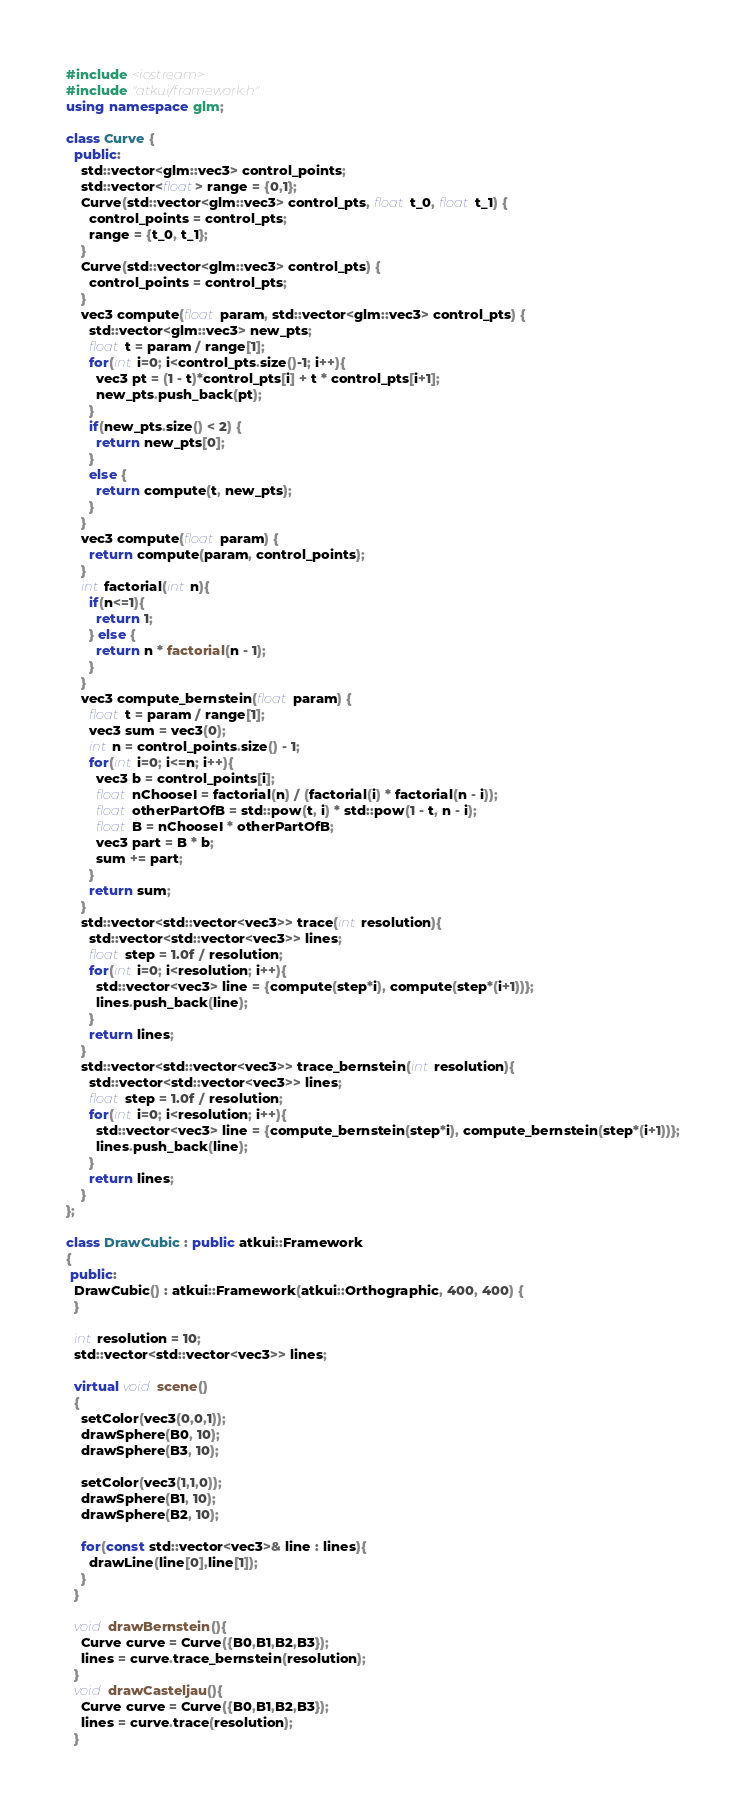Convert code to text. <code><loc_0><loc_0><loc_500><loc_500><_C++_>#include <iostream>
#include "atkui/framework.h"
using namespace glm;

class Curve {
  public:
    std::vector<glm::vec3> control_points;
    std::vector<float> range = {0,1};
    Curve(std::vector<glm::vec3> control_pts, float t_0, float t_1) {
      control_points = control_pts;
      range = {t_0, t_1};
    }
    Curve(std::vector<glm::vec3> control_pts) {
      control_points = control_pts;
    }
    vec3 compute(float param, std::vector<glm::vec3> control_pts) {
      std::vector<glm::vec3> new_pts;
      float t = param / range[1];
      for(int i=0; i<control_pts.size()-1; i++){
        vec3 pt = (1 - t)*control_pts[i] + t * control_pts[i+1];
        new_pts.push_back(pt);
      }
      if(new_pts.size() < 2) {
        return new_pts[0];
      }
      else {
        return compute(t, new_pts);
      }
    }
    vec3 compute(float param) {
      return compute(param, control_points);
    }
    int factorial(int n){
      if(n<=1){
        return 1;
      } else {
        return n * factorial(n - 1);
      }
    }
    vec3 compute_bernstein(float param) {
      float t = param / range[1];
      vec3 sum = vec3(0);
      int n = control_points.size() - 1;
      for(int i=0; i<=n; i++){
        vec3 b = control_points[i];
        float nChooseI = factorial(n) / (factorial(i) * factorial(n - i));
        float otherPartOfB = std::pow(t, i) * std::pow(1 - t, n - i);
        float B = nChooseI * otherPartOfB;
        vec3 part = B * b;
        sum += part;
      }
      return sum;
    }
    std::vector<std::vector<vec3>> trace(int resolution){
      std::vector<std::vector<vec3>> lines;
      float step = 1.0f / resolution;
      for(int i=0; i<resolution; i++){
        std::vector<vec3> line = {compute(step*i), compute(step*(i+1))};
        lines.push_back(line);
      }
      return lines;
    }
    std::vector<std::vector<vec3>> trace_bernstein(int resolution){
      std::vector<std::vector<vec3>> lines;
      float step = 1.0f / resolution;
      for(int i=0; i<resolution; i++){
        std::vector<vec3> line = {compute_bernstein(step*i), compute_bernstein(step*(i+1))};
        lines.push_back(line);
      }
      return lines;
    }
};

class DrawCubic : public atkui::Framework
{
 public:
  DrawCubic() : atkui::Framework(atkui::Orthographic, 400, 400) {
  }

  int resolution = 10;
  std::vector<std::vector<vec3>> lines;

  virtual void scene()
  {
    setColor(vec3(0,0,1));
    drawSphere(B0, 10);
    drawSphere(B3, 10);

    setColor(vec3(1,1,0));
    drawSphere(B1, 10);
    drawSphere(B2, 10);

    for(const std::vector<vec3>& line : lines){
      drawLine(line[0],line[1]);
    }
  }

  void drawBernstein(){
    Curve curve = Curve({B0,B1,B2,B3});
    lines = curve.trace_bernstein(resolution);
  }
  void drawCasteljau(){
    Curve curve = Curve({B0,B1,B2,B3});
    lines = curve.trace(resolution);
  }
</code> 